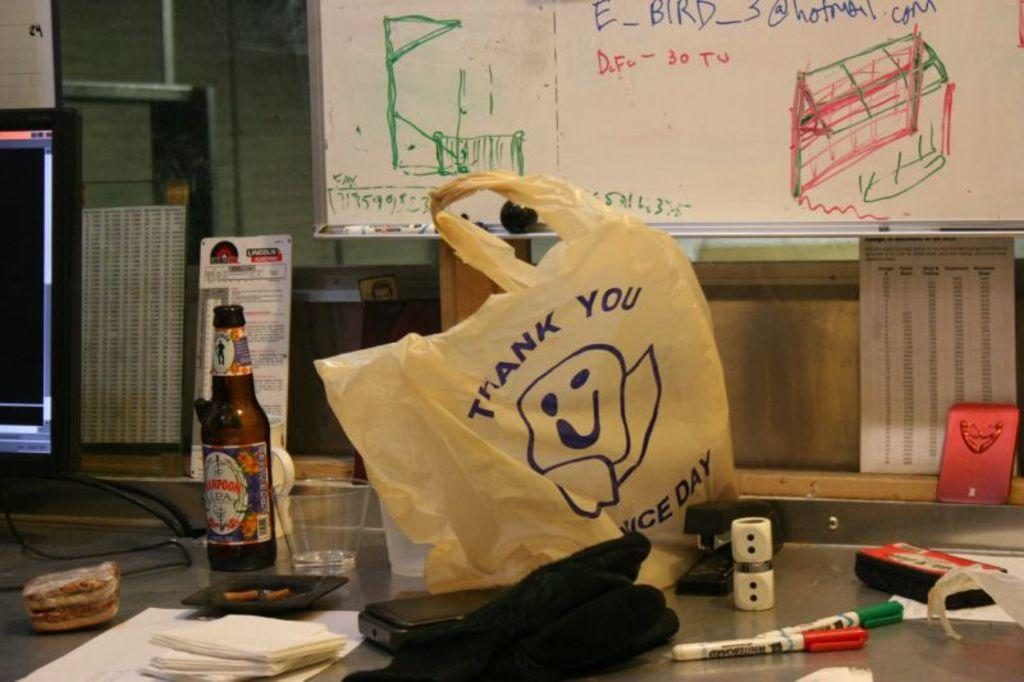What is one object visible in the image? There is a bottle in the image. What else can be seen in the image? There is a glass, tissues, markers, a cover on the floor, and a board in the image. What is the background of the image? There is a wall in the background of the image. What other item is present in the image? There is a screen in the image. What type of corn is being served at the protest in the image? There is no corn or protest present in the image. Can you read the letter that is being handed out at the event in the image? There is no letter or event present in the image. 